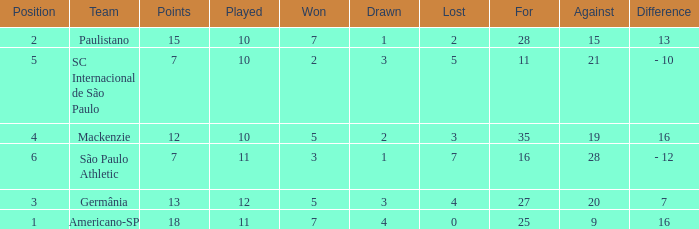Name the points for paulistano 15.0. 